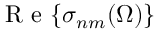<formula> <loc_0><loc_0><loc_500><loc_500>R e { \left \{ \sigma _ { n m } ( \Omega ) \right \} }</formula> 